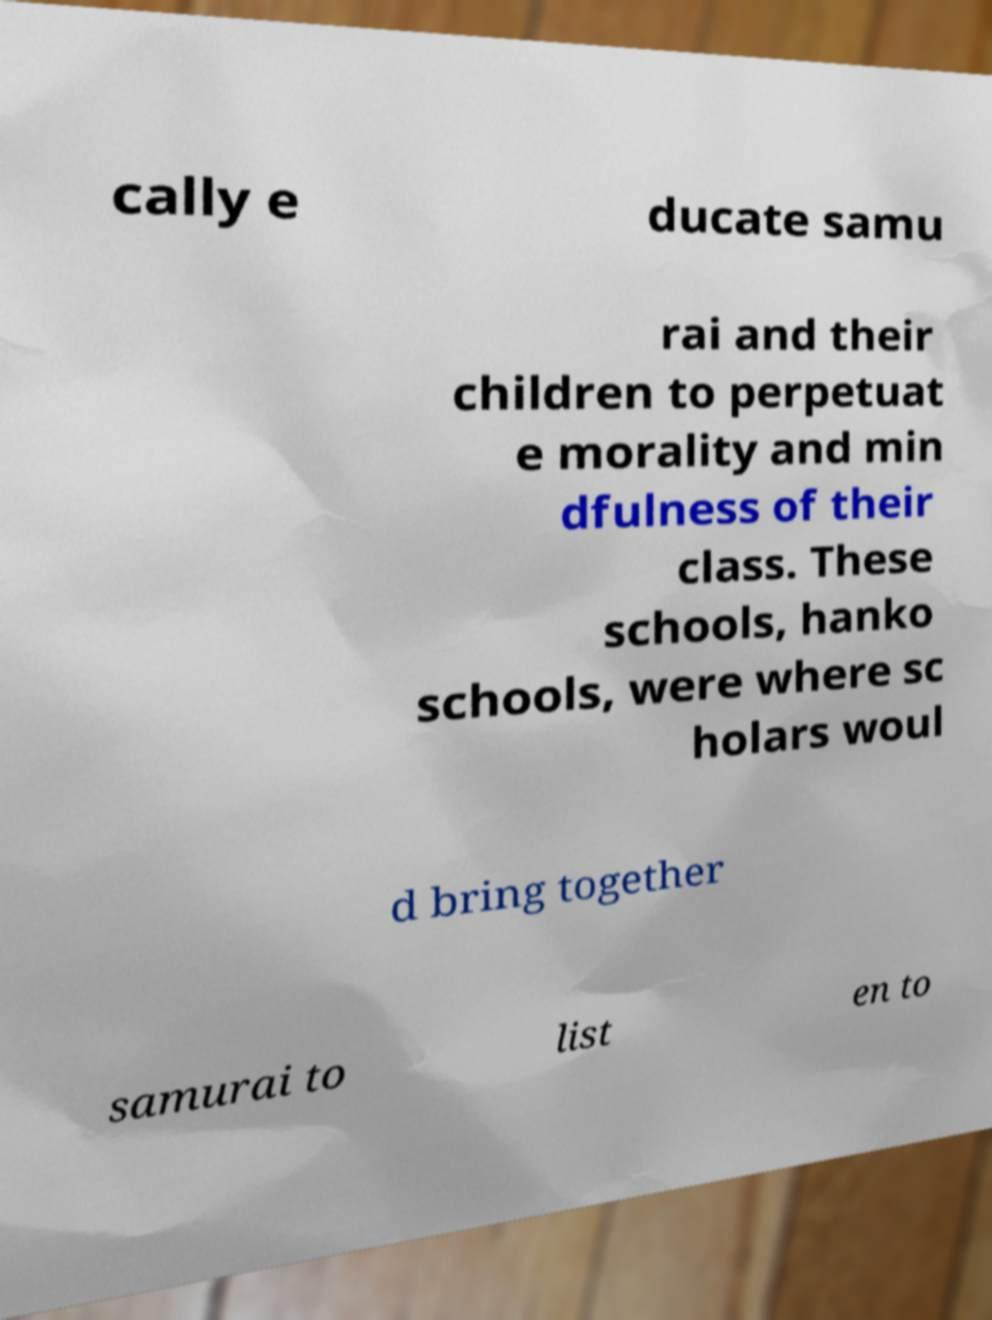Can you accurately transcribe the text from the provided image for me? cally e ducate samu rai and their children to perpetuat e morality and min dfulness of their class. These schools, hanko schools, were where sc holars woul d bring together samurai to list en to 